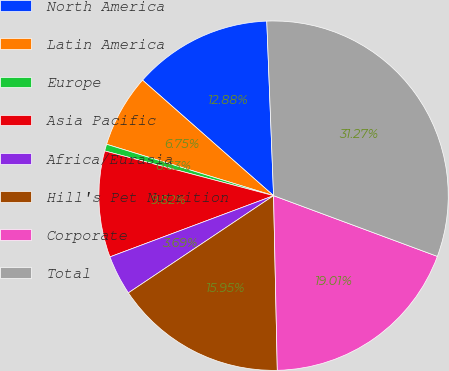<chart> <loc_0><loc_0><loc_500><loc_500><pie_chart><fcel>North America<fcel>Latin America<fcel>Europe<fcel>Asia Pacific<fcel>Africa/Eurasia<fcel>Hill's Pet Nutrition<fcel>Corporate<fcel>Total<nl><fcel>12.88%<fcel>6.75%<fcel>0.63%<fcel>9.82%<fcel>3.69%<fcel>15.95%<fcel>19.01%<fcel>31.27%<nl></chart> 